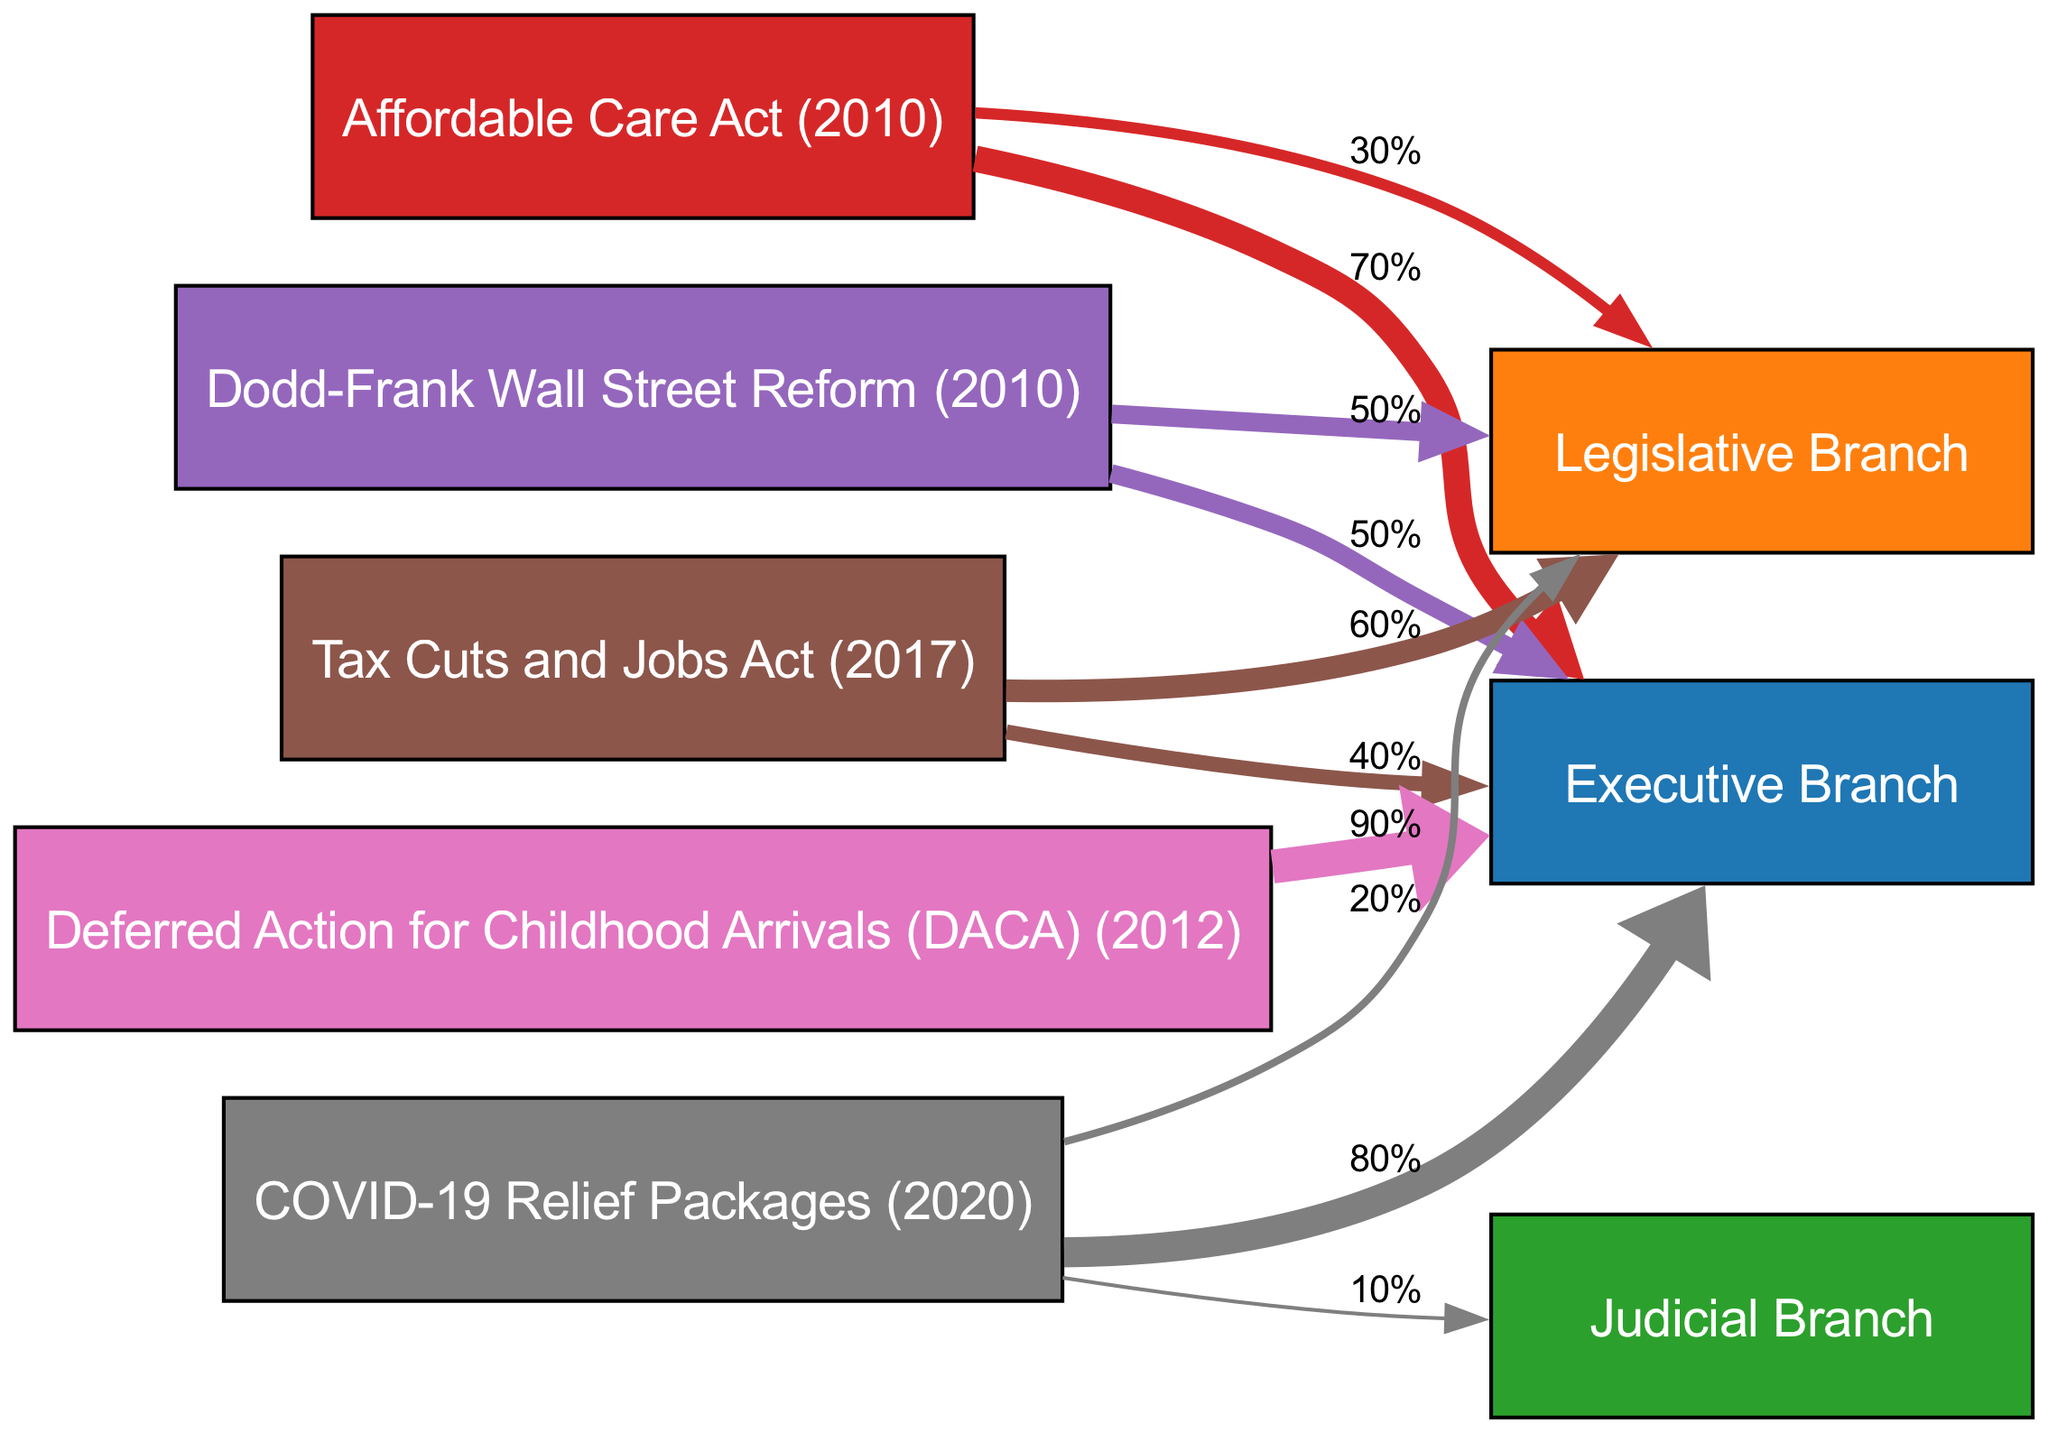What is the total percentage of power transition from the Affordable Care Act to the Executive Branch? The diagram shows that the Affordable Care Act has a power transition value of 70% directed towards the Executive Branch.
Answer: 70% Which landmark law has the highest percentage transition to the Executive Branch? Upon reviewing the diagram, the Deferred Action for Childhood Arrivals law has a transition value of 90%, which is the highest directed towards the Executive Branch.
Answer: Deferred Action for Childhood Arrivals How many nodes are present in the diagram? Counting the nodes in the diagram, there are a total of 8 nodes, which include 3 branches of government and 5 landmark laws.
Answer: 8 What is the total percentage of power transition from COVID-19 Relief Packages to the Legislative Branch? The diagram indicates that the COVID-19 Relief Packages have a transition value of 20% directed to the Legislative Branch.
Answer: 20% Which branch of government receives an equal percentage of power transition from the Dodd-Frank Wall Street Reform? The diagram shows that both the Executive and Legislative Branches each receive 50% of the power transition from the Dodd-Frank Wall Street Reform.
Answer: Executive Branch and Legislative Branch What is the power transition percentage from the Tax Cuts and Jobs Act to the Executive Branch? The diagram indicates a power transition of 40% from the Tax Cuts and Jobs Act to the Executive Branch.
Answer: 40% How does the total transition to the Judicial Branch compare among landmark laws? Looking at the diagram, the Judicial Branch has a total transition value of 10% from the COVID-19 Relief Packages only, which is its only source in this context.
Answer: 10% Which landmark legislation predominantly increases Executive Branch power? From the diagram, it can be noted that the Deferred Action for Childhood Arrivals has a substantial 90% transition to the Executive Branch, indicating it predominantly increases its power.
Answer: Deferred Action for Childhood Arrivals What is the total value of power transition from the COVID-19 Relief Packages, split among all branches of government? The total value is calculated by summing the percentages: 80% (Executive) + 20% (Legislative) + 10% (Judicial) = 110%.
Answer: 110% 